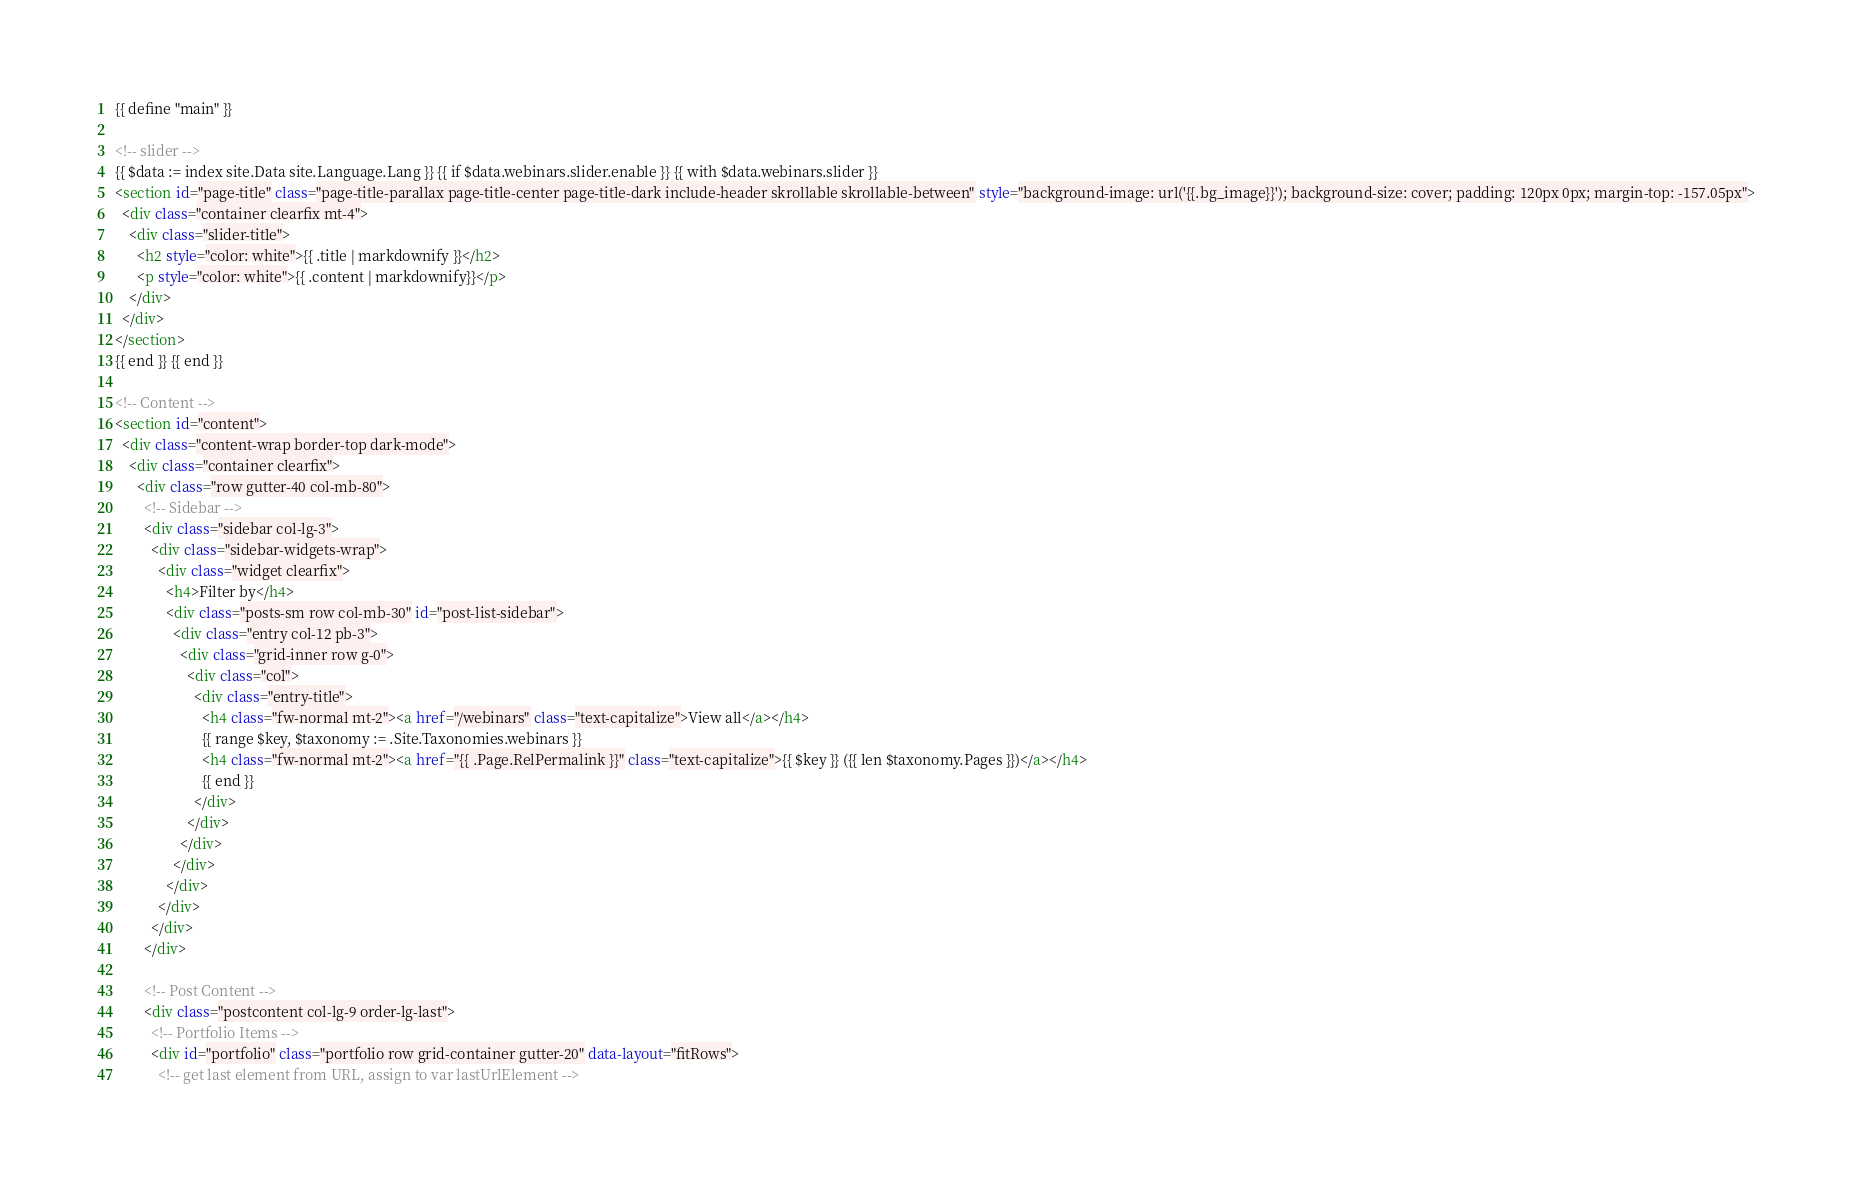Convert code to text. <code><loc_0><loc_0><loc_500><loc_500><_HTML_>{{ define "main" }}

<!-- slider -->
{{ $data := index site.Data site.Language.Lang }} {{ if $data.webinars.slider.enable }} {{ with $data.webinars.slider }}
<section id="page-title" class="page-title-parallax page-title-center page-title-dark include-header skrollable skrollable-between" style="background-image: url('{{.bg_image}}'); background-size: cover; padding: 120px 0px; margin-top: -157.05px">
  <div class="container clearfix mt-4">
    <div class="slider-title">
      <h2 style="color: white">{{ .title | markdownify }}</h2>
      <p style="color: white">{{ .content | markdownify}}</p>
    </div>
  </div>
</section>
{{ end }} {{ end }}

<!-- Content -->
<section id="content">
  <div class="content-wrap border-top dark-mode">
    <div class="container clearfix">
      <div class="row gutter-40 col-mb-80">
        <!-- Sidebar -->
        <div class="sidebar col-lg-3">
          <div class="sidebar-widgets-wrap">
            <div class="widget clearfix">
              <h4>Filter by</h4>
              <div class="posts-sm row col-mb-30" id="post-list-sidebar">
                <div class="entry col-12 pb-3">
                  <div class="grid-inner row g-0">
                    <div class="col">
                      <div class="entry-title">
                        <h4 class="fw-normal mt-2"><a href="/webinars" class="text-capitalize">View all</a></h4>
                        {{ range $key, $taxonomy := .Site.Taxonomies.webinars }}
                        <h4 class="fw-normal mt-2"><a href="{{ .Page.RelPermalink }}" class="text-capitalize">{{ $key }} ({{ len $taxonomy.Pages }})</a></h4>
                        {{ end }}
                      </div>
                    </div>
                  </div>
                </div>
              </div>
            </div>
          </div>
        </div>

        <!-- Post Content -->
        <div class="postcontent col-lg-9 order-lg-last">
          <!-- Portfolio Items -->
          <div id="portfolio" class="portfolio row grid-container gutter-20" data-layout="fitRows">
            <!-- get last element from URL, assign to var lastUrlElement --></code> 